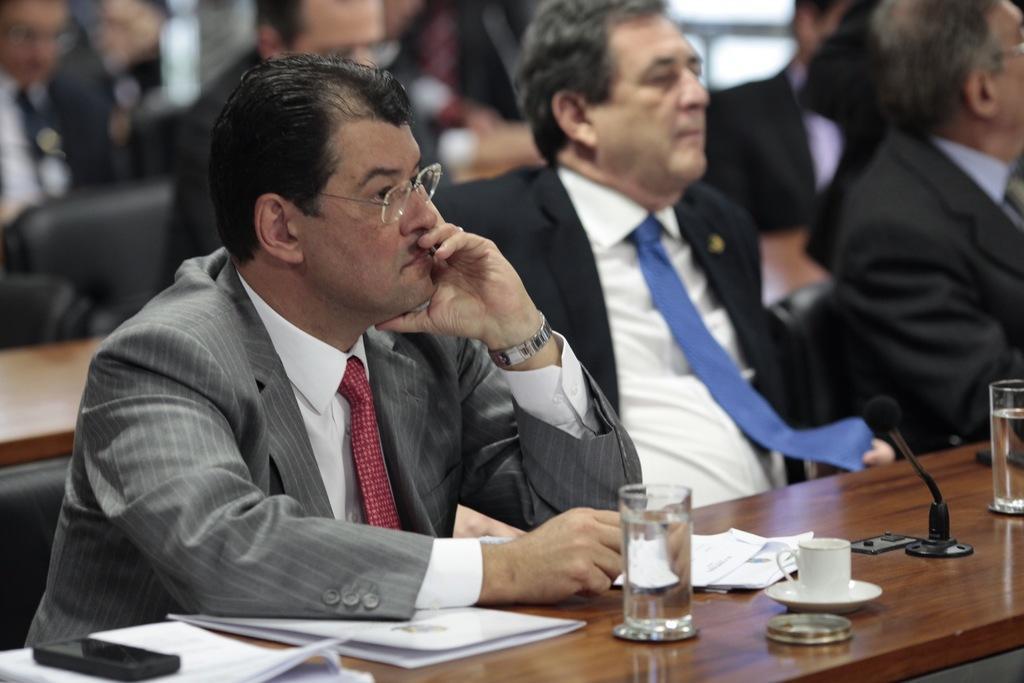Please provide a concise description of this image. There are some people sitting. Person on the left is wearing a watch and specs. In front of him there is a table. On the table there is a glasses, cup, saucer, mic, papers and a mobile phone. 